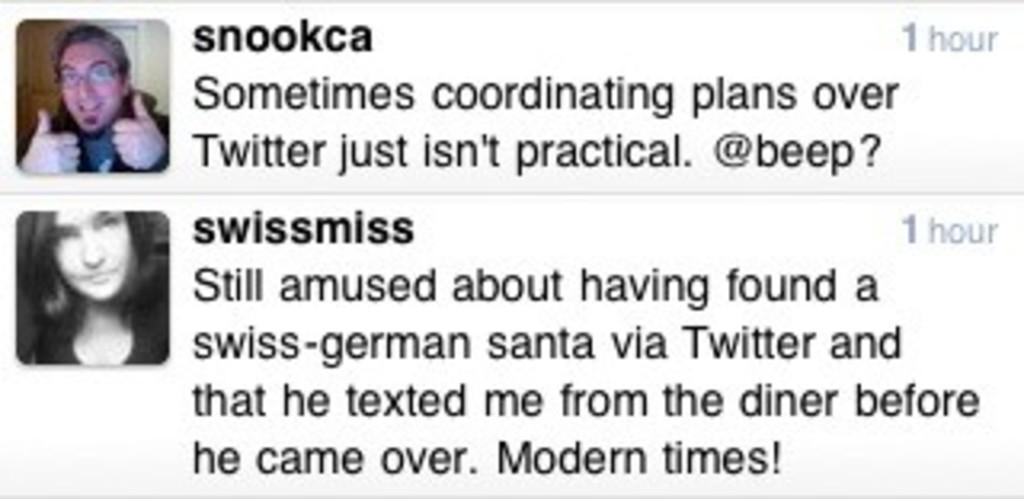What type of visual is the image? The image is a poster. What can be seen on the poster? There are depictions of people on the poster. Is there any text on the poster? Yes, there is text on the poster. What type of liquid is being taxed in the image? There is no mention of any liquid or tax in the image; it only features depictions of people and text. 